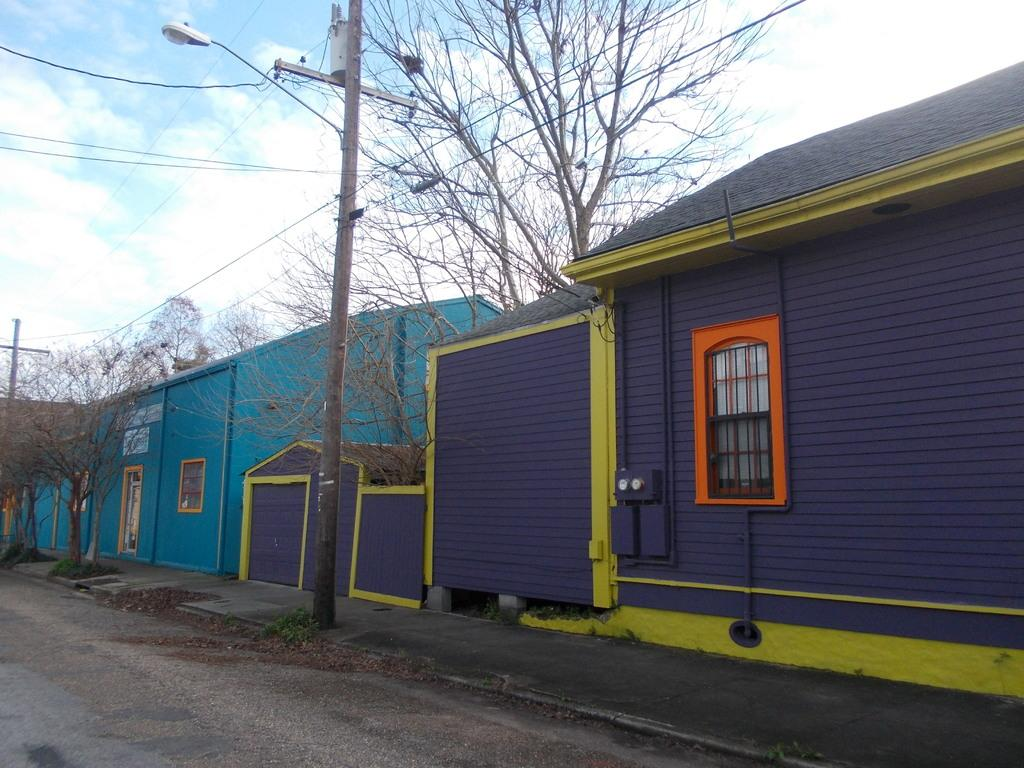What type of structures can be seen in the image? There are buildings in the image. What other natural elements are present in the image? There are trees in the image. What might indicate the presence of people or activity in the image? Current polls and a street lamp are visible in the image. What type of window covering can be seen in the image? Rolling shutters are visible in the image. What is visible at the top of the image? The sky is visible at the top of the image. What can be observed in the sky? Clouds are present in the sky. What type of song can be heard in the image? There is no audible sound in the image, so it is not possible to determine if a song can be heard. How many wings are visible on the buildings in the image? There are no wings present on the buildings in the image. 